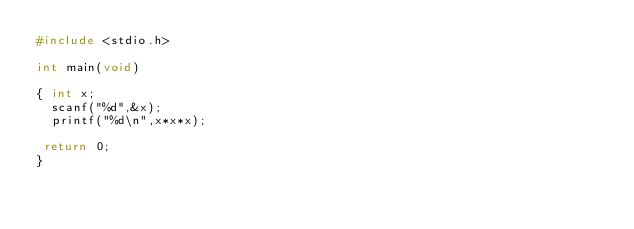Convert code to text. <code><loc_0><loc_0><loc_500><loc_500><_C_>#include <stdio.h>

int main(void)

{ int x;
	scanf("%d",&x);
	printf("%d\n",x*x*x);

 return 0;
}</code> 